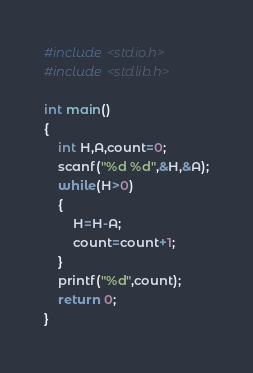Convert code to text. <code><loc_0><loc_0><loc_500><loc_500><_C_>#include <stdio.h>
#include <stdlib.h>

int main()
{
    int H,A,count=0;
    scanf("%d %d",&H,&A);
    while(H>0)
    {
        H=H-A;
        count=count+1;
    }
    printf("%d",count);
    return 0;
}
</code> 